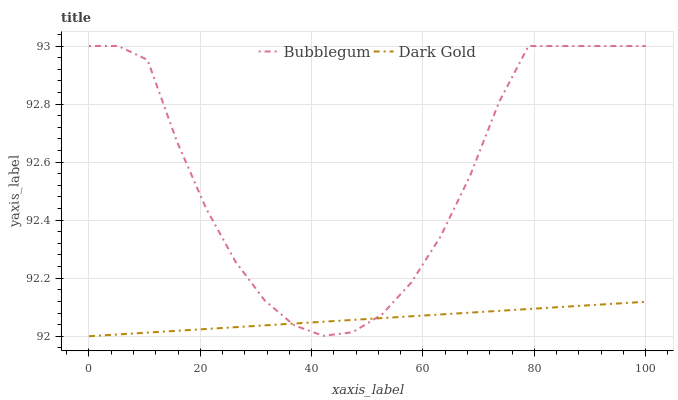Does Dark Gold have the minimum area under the curve?
Answer yes or no. Yes. Does Bubblegum have the maximum area under the curve?
Answer yes or no. Yes. Does Dark Gold have the maximum area under the curve?
Answer yes or no. No. Is Dark Gold the smoothest?
Answer yes or no. Yes. Is Bubblegum the roughest?
Answer yes or no. Yes. Is Dark Gold the roughest?
Answer yes or no. No. Does Dark Gold have the lowest value?
Answer yes or no. Yes. Does Bubblegum have the highest value?
Answer yes or no. Yes. Does Dark Gold have the highest value?
Answer yes or no. No. Does Bubblegum intersect Dark Gold?
Answer yes or no. Yes. Is Bubblegum less than Dark Gold?
Answer yes or no. No. Is Bubblegum greater than Dark Gold?
Answer yes or no. No. 